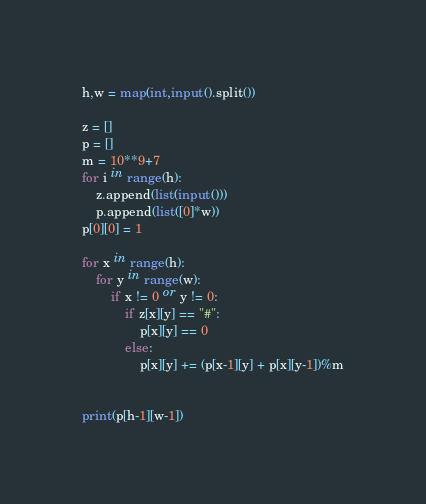<code> <loc_0><loc_0><loc_500><loc_500><_Python_>h,w = map(int,input().split())

z = []
p = []
m = 10**9+7
for i in range(h):
    z.append(list(input()))
    p.append(list([0]*w))
p[0][0] = 1

for x in range(h):
    for y in range(w):
        if x != 0 or y != 0:
            if z[x][y] == "#":
                p[x][y] == 0
            else:
                p[x][y] += (p[x-1][y] + p[x][y-1])%m
               
                
print(p[h-1][w-1])</code> 